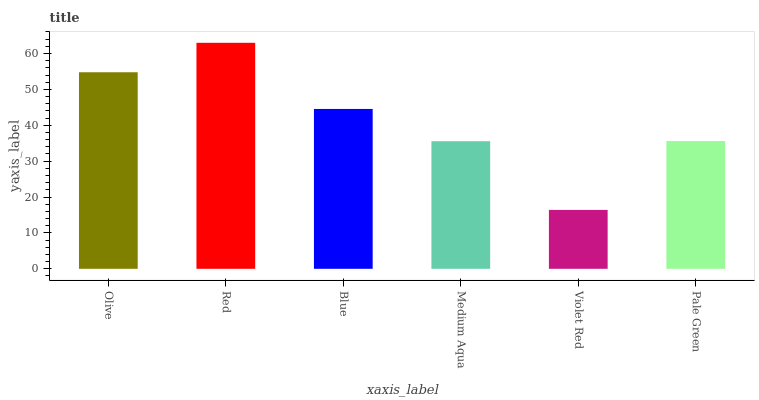Is Blue the minimum?
Answer yes or no. No. Is Blue the maximum?
Answer yes or no. No. Is Red greater than Blue?
Answer yes or no. Yes. Is Blue less than Red?
Answer yes or no. Yes. Is Blue greater than Red?
Answer yes or no. No. Is Red less than Blue?
Answer yes or no. No. Is Blue the high median?
Answer yes or no. Yes. Is Pale Green the low median?
Answer yes or no. Yes. Is Olive the high median?
Answer yes or no. No. Is Medium Aqua the low median?
Answer yes or no. No. 